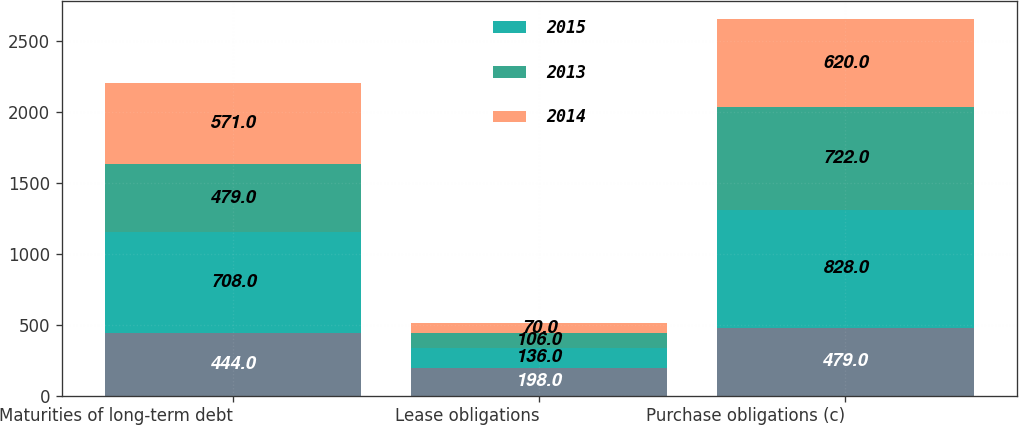Convert chart to OTSL. <chart><loc_0><loc_0><loc_500><loc_500><stacked_bar_chart><ecel><fcel>Maturities of long-term debt<fcel>Lease obligations<fcel>Purchase obligations (c)<nl><fcel>nan<fcel>444<fcel>198<fcel>479<nl><fcel>2015<fcel>708<fcel>136<fcel>828<nl><fcel>2013<fcel>479<fcel>106<fcel>722<nl><fcel>2014<fcel>571<fcel>70<fcel>620<nl></chart> 